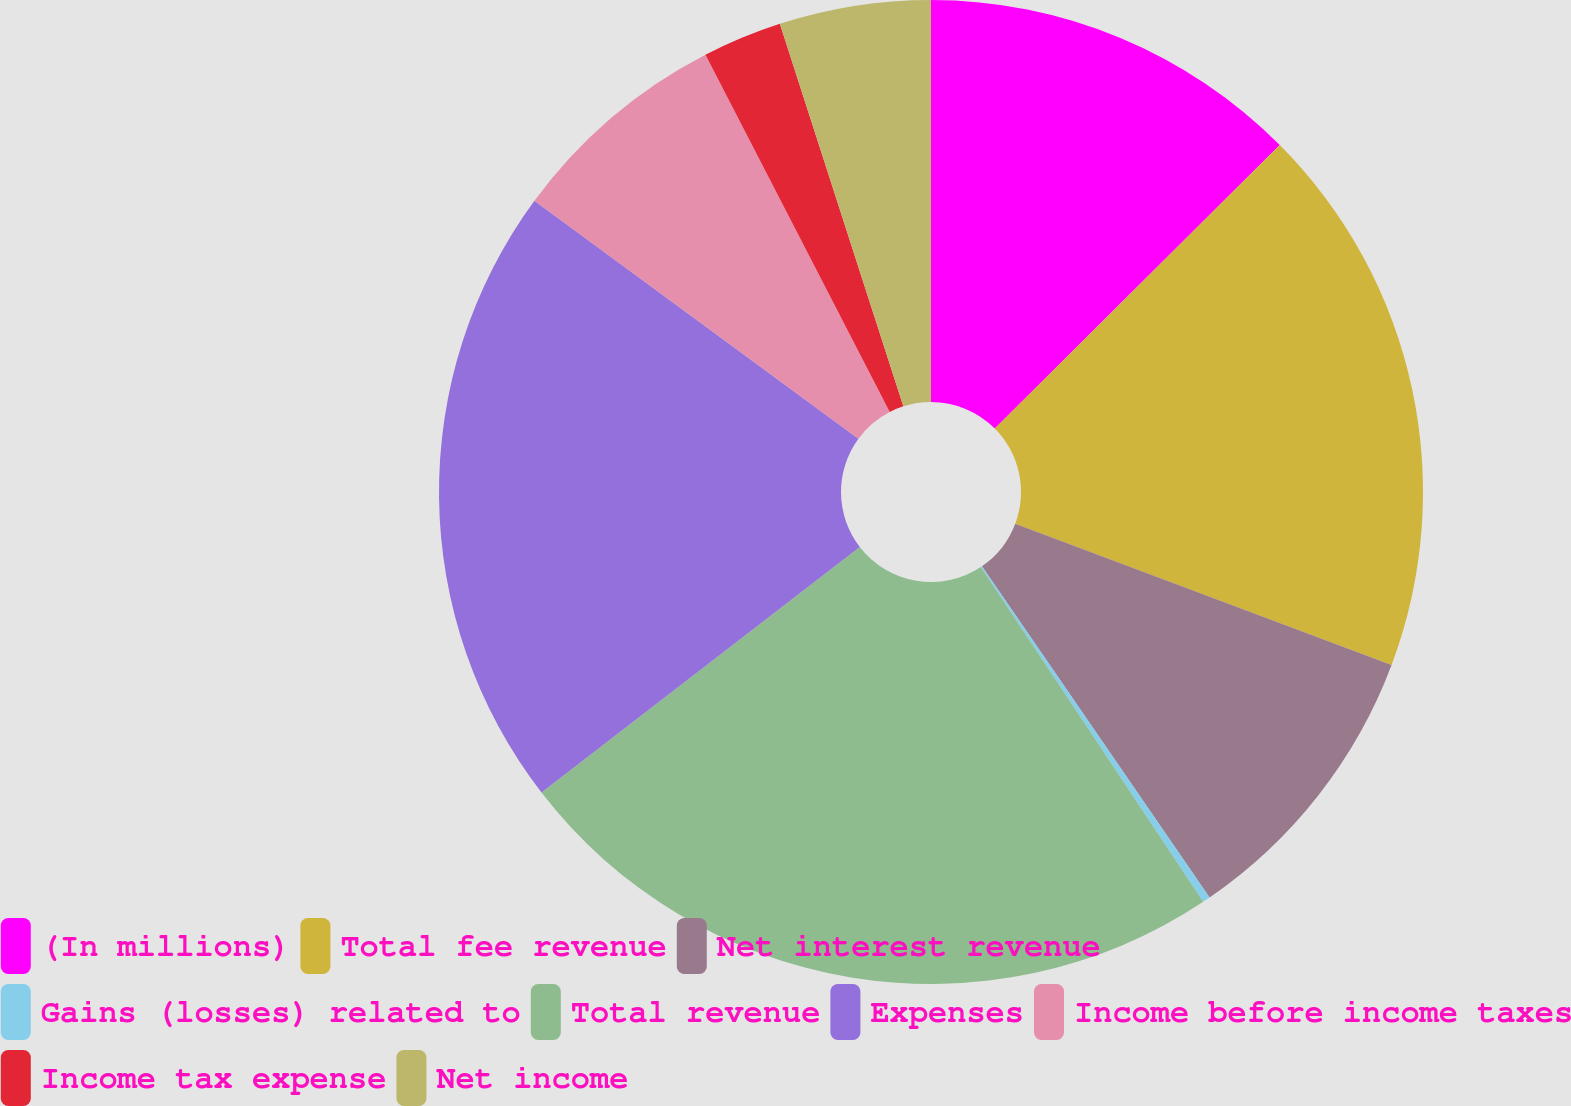Convert chart. <chart><loc_0><loc_0><loc_500><loc_500><pie_chart><fcel>(In millions)<fcel>Total fee revenue<fcel>Net interest revenue<fcel>Gains (losses) related to<fcel>Total revenue<fcel>Expenses<fcel>Income before income taxes<fcel>Income tax expense<fcel>Net income<nl><fcel>12.54%<fcel>18.18%<fcel>9.7%<fcel>0.25%<fcel>23.87%<fcel>20.54%<fcel>7.34%<fcel>2.61%<fcel>4.97%<nl></chart> 